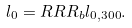Convert formula to latex. <formula><loc_0><loc_0><loc_500><loc_500>l _ { 0 } = R R R _ { b } l _ { 0 , 3 0 0 } .</formula> 